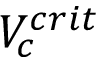Convert formula to latex. <formula><loc_0><loc_0><loc_500><loc_500>V _ { c } ^ { c r i t }</formula> 